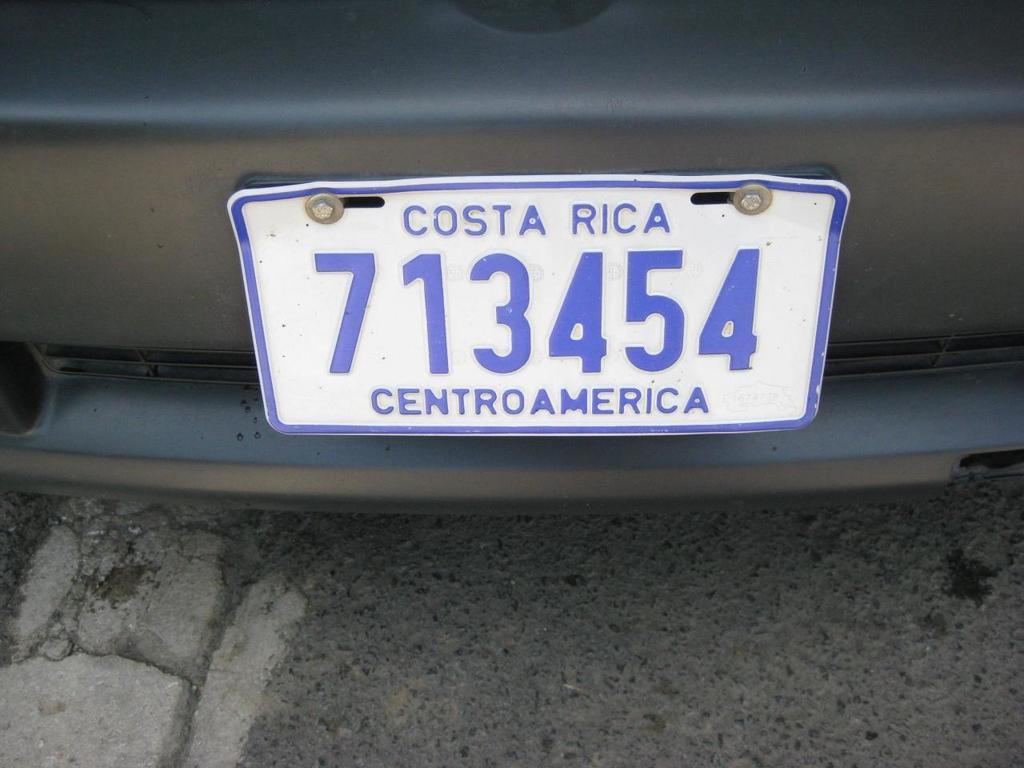What country is this?
Keep it short and to the point. Costa rica. 